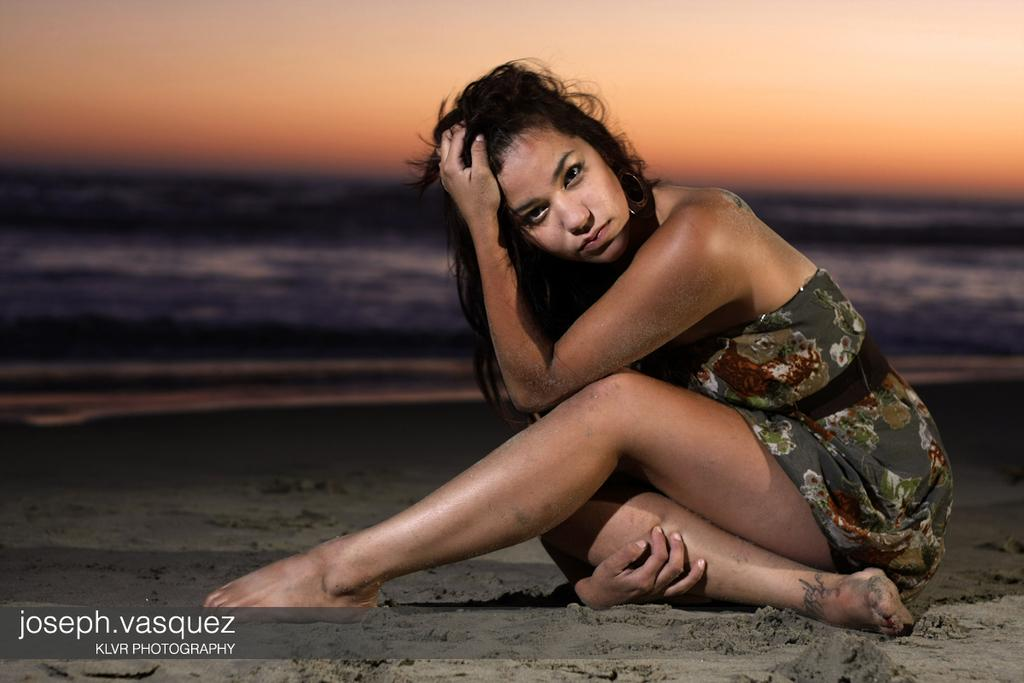Who is the main subject in the image? There is a woman sitting in the center of the image. What is the surface beneath the woman? There is sand at the bottom of the image. What type of location can be seen in the background? There is a beach in the background of the image. What type of bells can be heard ringing in the image? There are no bells present in the image, and therefore no sound can be heard. 